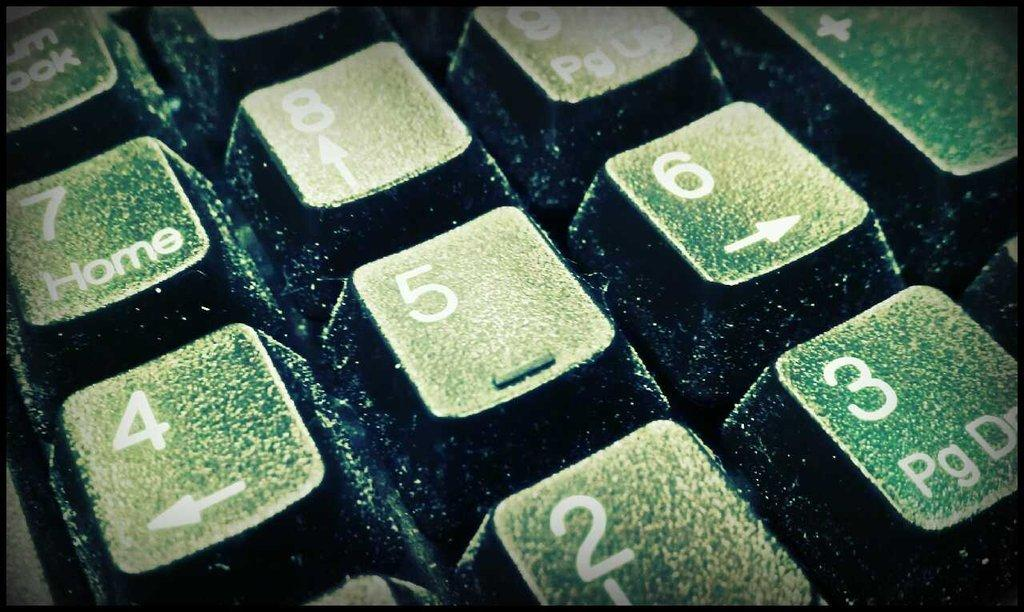Provide a one-sentence caption for the provided image. The number 5 key is in the center of a partial image of a keyboard. 